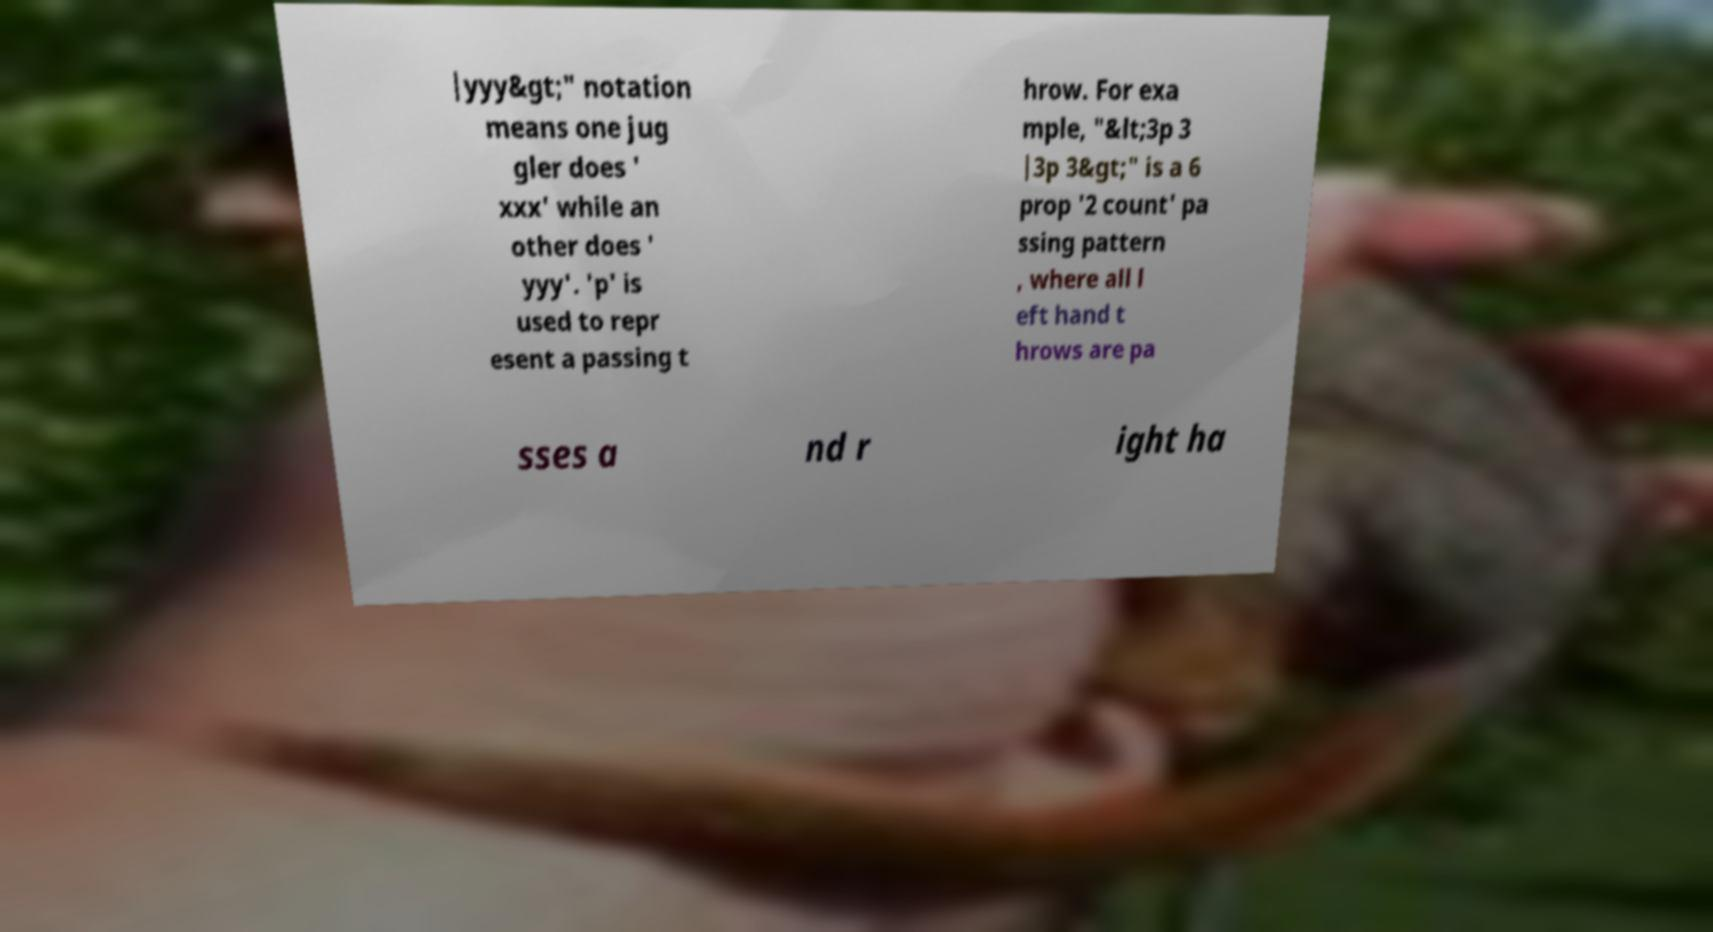Please identify and transcribe the text found in this image. |yyy&gt;" notation means one jug gler does ' xxx' while an other does ' yyy'. 'p' is used to repr esent a passing t hrow. For exa mple, "&lt;3p 3 |3p 3&gt;" is a 6 prop '2 count' pa ssing pattern , where all l eft hand t hrows are pa sses a nd r ight ha 